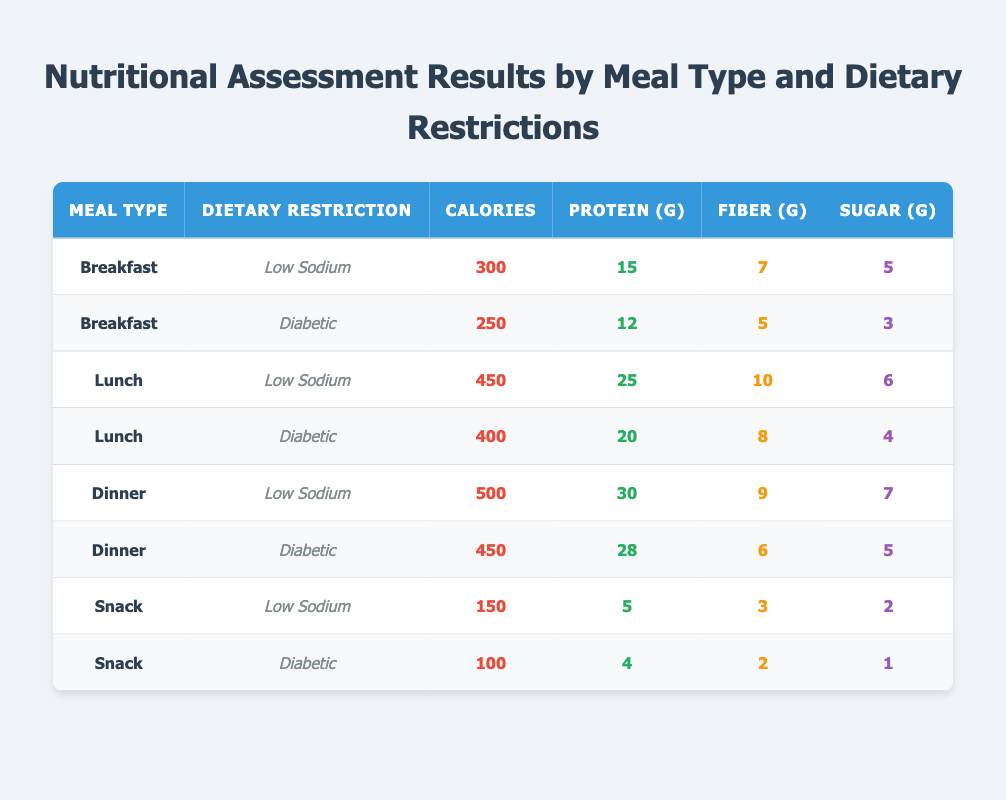What is the total calorie count for all meals with a "Diabetic" dietary restriction? To find the total calorie count for all meals with a "Diabetic" dietary restriction, I need to sum the calories from each relevant row in the table: Breakfast (250), Lunch (400), Dinner (450), and Snack (100). So, the total is 250 + 400 + 450 + 100 = 1200 calories.
Answer: 1200 What is the protein content of the "Low Sodium" lunch meal? From the table, the "Low Sodium" lunch meal has a protein content of 25 grams, as directly listed in the corresponding row.
Answer: 25 Is there a dinner meal option that follows both dietary restrictions? Yes, there are two dinner meal options, one for "Low Sodium" and one for "Diabetic", but no single meal option meets both dietary restrictions at the same time. Therefore, the answer is no.
Answer: No Which meal type has the highest sugar content, and what is the value? Looking through the table, the highest sugar content is found in the "Dinner" with "Low Sodium" dietary restriction, which has 7 grams of sugar.
Answer: Dinner, 7 What is the average calories for the "Snack" meals? The calorie values for the "Snack" meals are 150 and 100. To find the average, add them together (150 + 100 = 250) and then divide by the number of snacks (2). Thus, the average is 250 / 2 = 125.
Answer: 125 How much fiber is available in the "Breakfast" meal with a "Diabetic" dietary restriction? According to the table, the "Breakfast" meal that follows the "Diabetic" dietary restriction contains 5 grams of fiber, as indicated in its corresponding row.
Answer: 5 What is the total amount of protein across all "Low Sodium" meals? To calculate the total protein for "Low Sodium" meals, I add the protein values from each relevant meal: Breakfast (15), Lunch (25), Dinner (30), and Snack (5). The total protein is 15 + 25 + 30 + 5 = 75 grams.
Answer: 75 Which meal type has the least amount of calories for a "Diabetic" dietary restriction? The "Snack" meal option has the least calories for a "Diabetic" dietary restriction at 100 calories, which is lower than the Breakfast (250), Lunch (400), and Dinner (450) options.
Answer: Snack, 100 